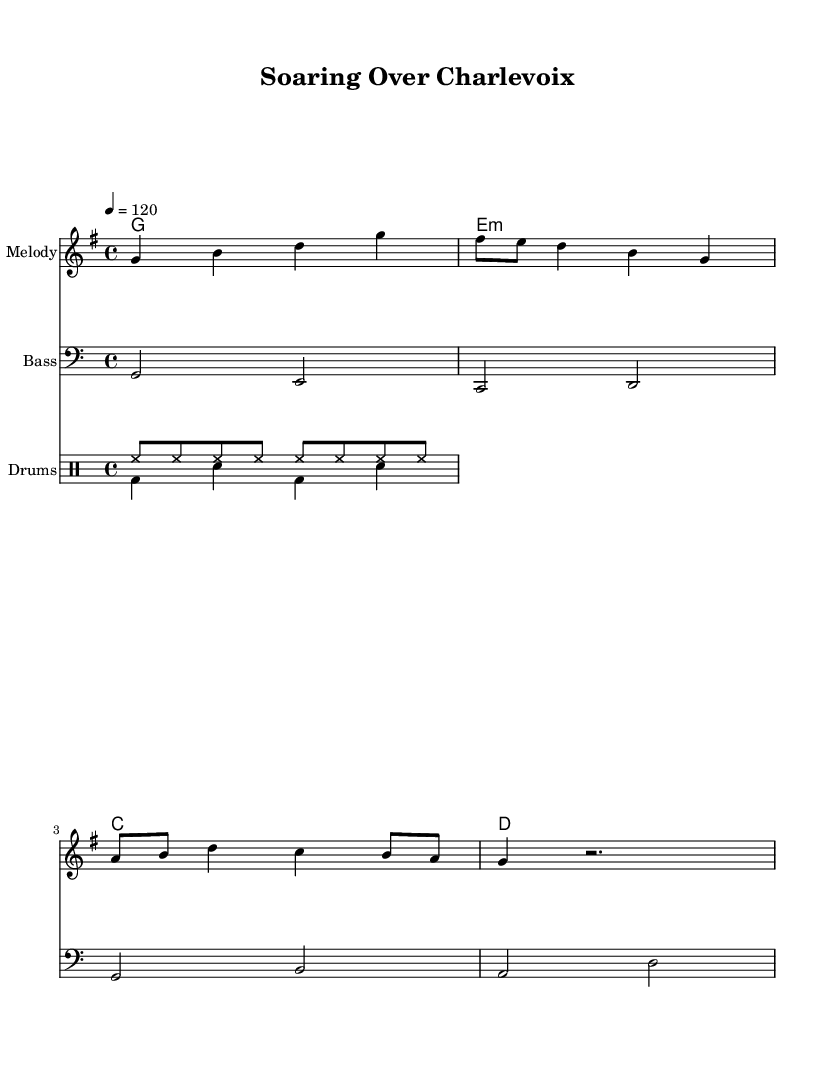What is the key signature of this music? The key signature is G major, which has one sharp (F#). This can be determined by looking for the key signature symbol at the beginning of the staff, which is consistent with the notes presented.
Answer: G major What is the time signature of this piece? The time signature is 4/4, indicated at the beginning of the music. This means there are four beats per measure and the quarter note gets the beat.
Answer: 4/4 What tempo is indicated for this piece? The tempo marking is 120 BPM, shown at the beginning of the score with "4 = 120." This indicates the speed at which the piece should be played, in beats per minute.
Answer: 120 What are the primary instruments used in this music? The primary instruments are the melody, bass, and drums, as shown by the different staves labeled "Melody," "Bass," and "Drums" in the score. This indicates a typical disco music arrangement.
Answer: Melody, Bass, Drums How many measures are in the harmony section? There are four measures in the harmony section, as identified by the four chords shown in the chord mode. Each chord represents one measure in the score.
Answer: 4 What style of rhythm is used for the drums? The rhythm used for the drums features a combination of hi-hat patterns and bass drum/snares, typical of disco music to maintain an upbeat and danceable feel. This can be seen in the drum patterns presented in the score.
Answer: Upbeat disco rhythm What is the highest note in the melody? The highest note in the melody is G, which can be found at the starting note of the melody and is visible when following the note placements on the staff.
Answer: G 